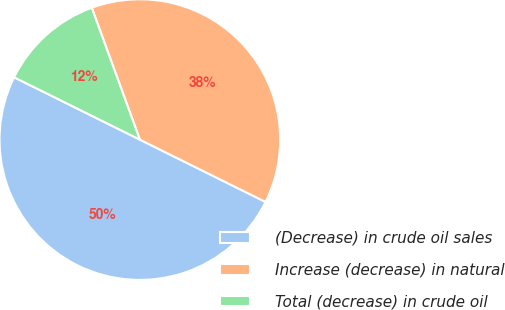Convert chart to OTSL. <chart><loc_0><loc_0><loc_500><loc_500><pie_chart><fcel>(Decrease) in crude oil sales<fcel>Increase (decrease) in natural<fcel>Total (decrease) in crude oil<nl><fcel>50.0%<fcel>37.89%<fcel>12.11%<nl></chart> 